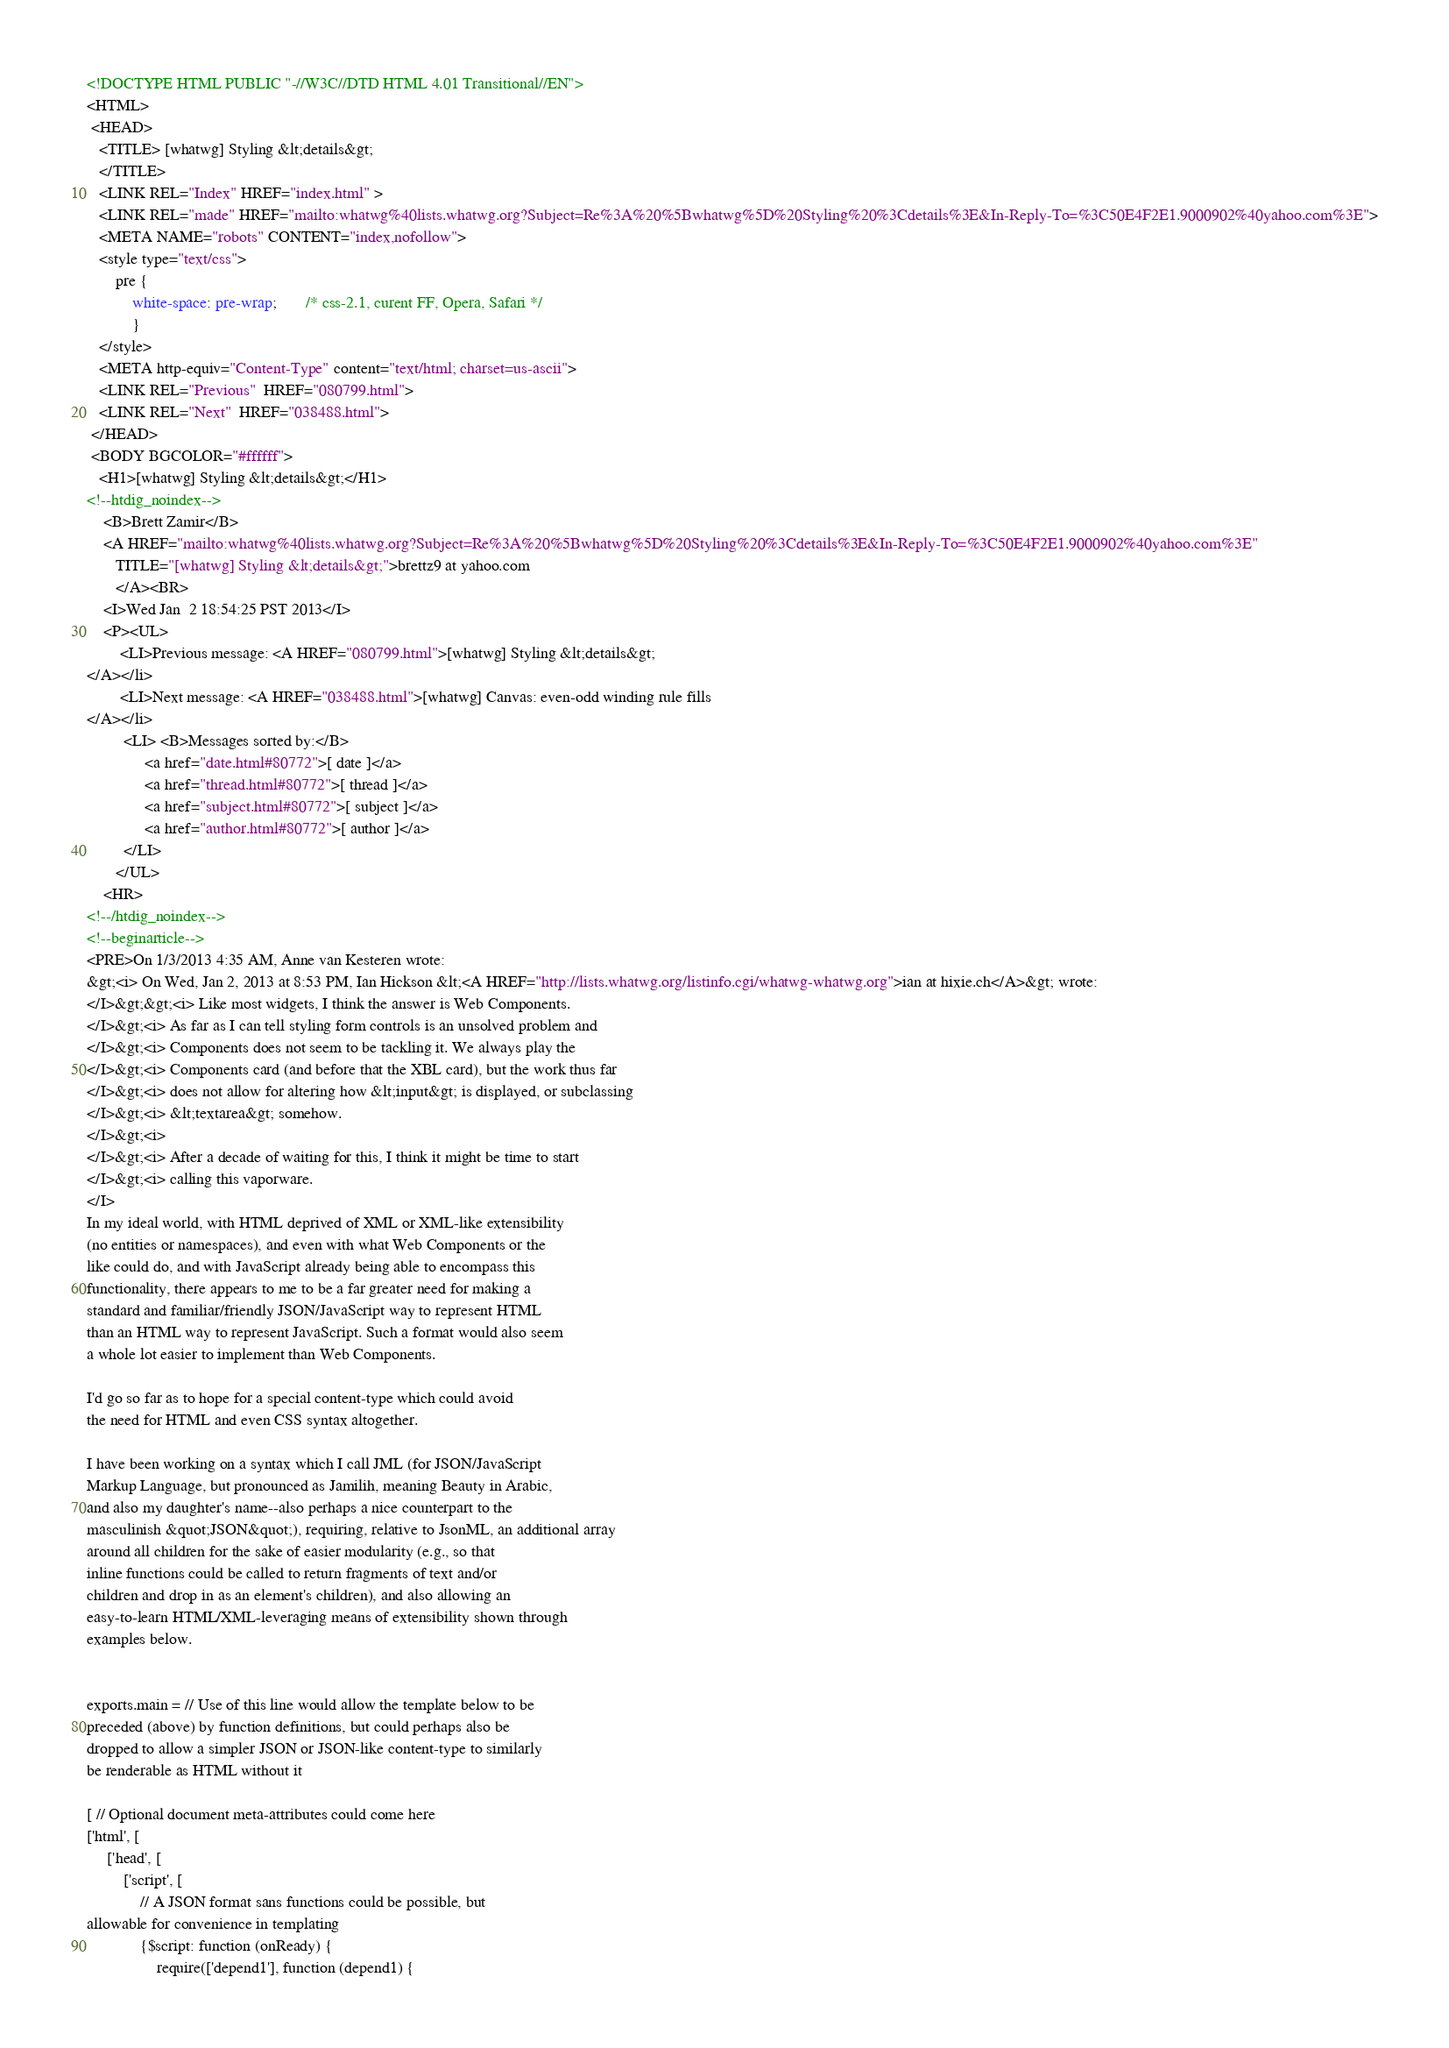Convert code to text. <code><loc_0><loc_0><loc_500><loc_500><_HTML_><!DOCTYPE HTML PUBLIC "-//W3C//DTD HTML 4.01 Transitional//EN">
<HTML>
 <HEAD>
   <TITLE> [whatwg] Styling &lt;details&gt;
   </TITLE>
   <LINK REL="Index" HREF="index.html" >
   <LINK REL="made" HREF="mailto:whatwg%40lists.whatwg.org?Subject=Re%3A%20%5Bwhatwg%5D%20Styling%20%3Cdetails%3E&In-Reply-To=%3C50E4F2E1.9000902%40yahoo.com%3E">
   <META NAME="robots" CONTENT="index,nofollow">
   <style type="text/css">
       pre {
           white-space: pre-wrap;       /* css-2.1, curent FF, Opera, Safari */
           }
   </style>
   <META http-equiv="Content-Type" content="text/html; charset=us-ascii">
   <LINK REL="Previous"  HREF="080799.html">
   <LINK REL="Next"  HREF="038488.html">
 </HEAD>
 <BODY BGCOLOR="#ffffff">
   <H1>[whatwg] Styling &lt;details&gt;</H1>
<!--htdig_noindex-->
    <B>Brett Zamir</B> 
    <A HREF="mailto:whatwg%40lists.whatwg.org?Subject=Re%3A%20%5Bwhatwg%5D%20Styling%20%3Cdetails%3E&In-Reply-To=%3C50E4F2E1.9000902%40yahoo.com%3E"
       TITLE="[whatwg] Styling &lt;details&gt;">brettz9 at yahoo.com
       </A><BR>
    <I>Wed Jan  2 18:54:25 PST 2013</I>
    <P><UL>
        <LI>Previous message: <A HREF="080799.html">[whatwg] Styling &lt;details&gt;
</A></li>
        <LI>Next message: <A HREF="038488.html">[whatwg] Canvas: even-odd winding rule fills
</A></li>
         <LI> <B>Messages sorted by:</B> 
              <a href="date.html#80772">[ date ]</a>
              <a href="thread.html#80772">[ thread ]</a>
              <a href="subject.html#80772">[ subject ]</a>
              <a href="author.html#80772">[ author ]</a>
         </LI>
       </UL>
    <HR>  
<!--/htdig_noindex-->
<!--beginarticle-->
<PRE>On 1/3/2013 4:35 AM, Anne van Kesteren wrote:
&gt;<i> On Wed, Jan 2, 2013 at 8:53 PM, Ian Hickson &lt;<A HREF="http://lists.whatwg.org/listinfo.cgi/whatwg-whatwg.org">ian at hixie.ch</A>&gt; wrote:
</I>&gt;&gt;<i> Like most widgets, I think the answer is Web Components.
</I>&gt;<i> As far as I can tell styling form controls is an unsolved problem and
</I>&gt;<i> Components does not seem to be tackling it. We always play the
</I>&gt;<i> Components card (and before that the XBL card), but the work thus far
</I>&gt;<i> does not allow for altering how &lt;input&gt; is displayed, or subclassing
</I>&gt;<i> &lt;textarea&gt; somehow.
</I>&gt;<i>
</I>&gt;<i> After a decade of waiting for this, I think it might be time to start
</I>&gt;<i> calling this vaporware.
</I>
In my ideal world, with HTML deprived of XML or XML-like extensibility 
(no entities or namespaces), and even with what Web Components or the 
like could do, and with JavaScript already being able to encompass this 
functionality, there appears to me to be a far greater need for making a 
standard and familiar/friendly JSON/JavaScript way to represent HTML 
than an HTML way to represent JavaScript. Such a format would also seem 
a whole lot easier to implement than Web Components.

I'd go so far as to hope for a special content-type which could avoid 
the need for HTML and even CSS syntax altogether.

I have been working on a syntax which I call JML (for JSON/JavaScript 
Markup Language, but pronounced as Jamilih, meaning Beauty in Arabic, 
and also my daughter's name--also perhaps a nice counterpart to the 
masculinish &quot;JSON&quot;), requiring, relative to JsonML, an additional array 
around all children for the sake of easier modularity (e.g., so that 
inline functions could be called to return fragments of text and/or 
children and drop in as an element's children), and also allowing an 
easy-to-learn HTML/XML-leveraging means of extensibility shown through 
examples below.


exports.main = // Use of this line would allow the template below to be 
preceded (above) by function definitions, but could perhaps also be 
dropped to allow a simpler JSON or JSON-like content-type to similarly 
be renderable as HTML without it

[ // Optional document meta-attributes could come here
['html', [
     ['head', [
         ['script', [
             // A JSON format sans functions could be possible, but 
allowable for convenience in templating
             {$script: function (onReady) {
                 require(['depend1'], function (depend1) {</code> 